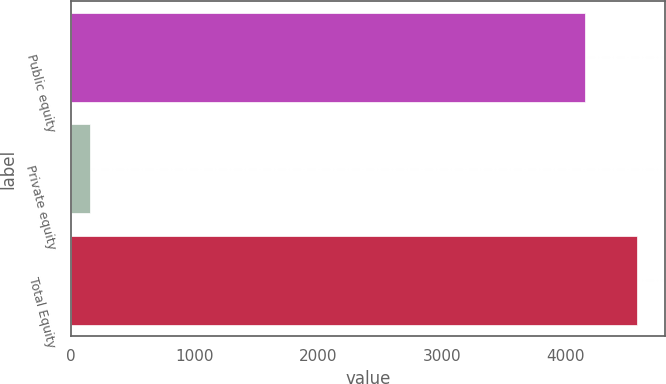Convert chart. <chart><loc_0><loc_0><loc_500><loc_500><bar_chart><fcel>Public equity<fcel>Private equity<fcel>Total Equity<nl><fcel>4162<fcel>152<fcel>4578.2<nl></chart> 